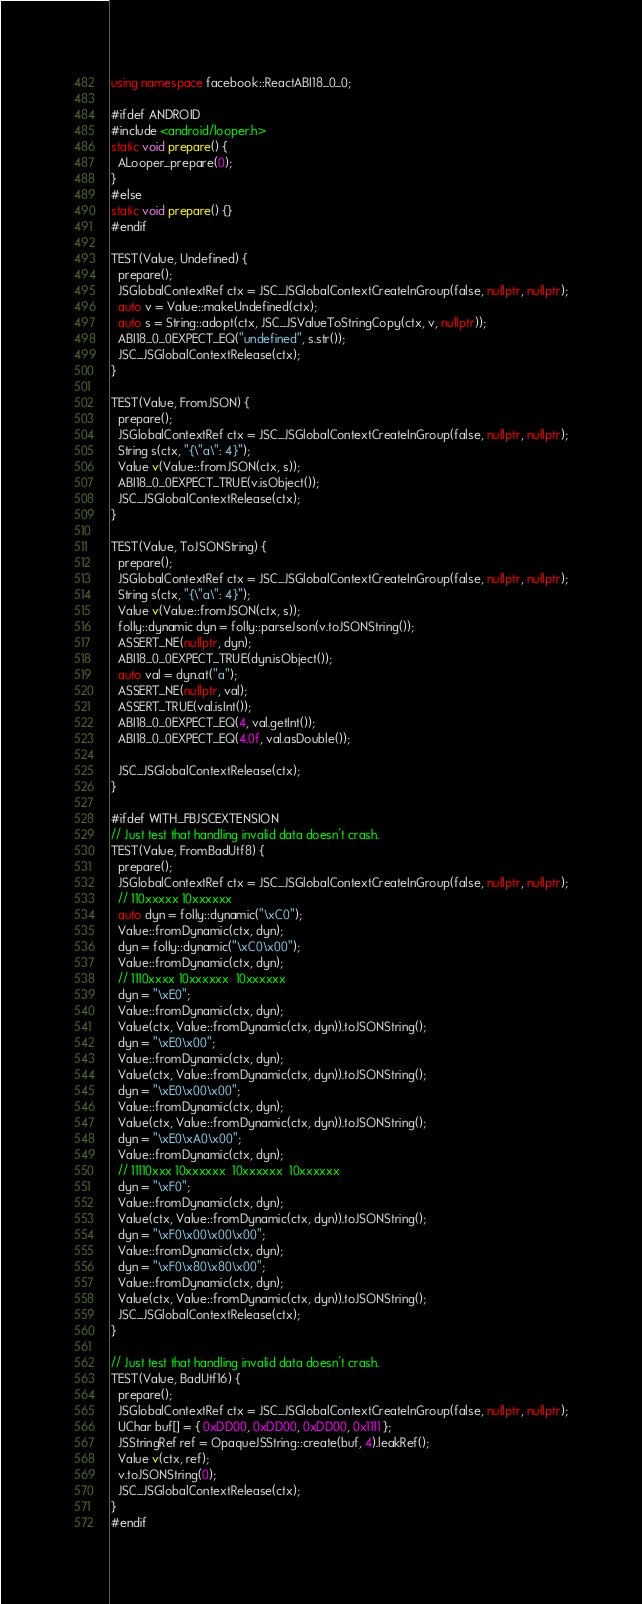<code> <loc_0><loc_0><loc_500><loc_500><_C++_>using namespace facebook::ReactABI18_0_0;

#ifdef ANDROID
#include <android/looper.h>
static void prepare() {
  ALooper_prepare(0);
}
#else
static void prepare() {}
#endif

TEST(Value, Undefined) {
  prepare();
  JSGlobalContextRef ctx = JSC_JSGlobalContextCreateInGroup(false, nullptr, nullptr);
  auto v = Value::makeUndefined(ctx);
  auto s = String::adopt(ctx, JSC_JSValueToStringCopy(ctx, v, nullptr));
  ABI18_0_0EXPECT_EQ("undefined", s.str());
  JSC_JSGlobalContextRelease(ctx);
}

TEST(Value, FromJSON) {
  prepare();
  JSGlobalContextRef ctx = JSC_JSGlobalContextCreateInGroup(false, nullptr, nullptr);
  String s(ctx, "{\"a\": 4}");
  Value v(Value::fromJSON(ctx, s));
  ABI18_0_0EXPECT_TRUE(v.isObject());
  JSC_JSGlobalContextRelease(ctx);
}

TEST(Value, ToJSONString) {
  prepare();
  JSGlobalContextRef ctx = JSC_JSGlobalContextCreateInGroup(false, nullptr, nullptr);
  String s(ctx, "{\"a\": 4}");
  Value v(Value::fromJSON(ctx, s));
  folly::dynamic dyn = folly::parseJson(v.toJSONString());
  ASSERT_NE(nullptr, dyn);
  ABI18_0_0EXPECT_TRUE(dyn.isObject());
  auto val = dyn.at("a");
  ASSERT_NE(nullptr, val);
  ASSERT_TRUE(val.isInt());
  ABI18_0_0EXPECT_EQ(4, val.getInt());
  ABI18_0_0EXPECT_EQ(4.0f, val.asDouble());

  JSC_JSGlobalContextRelease(ctx);
}

#ifdef WITH_FBJSCEXTENSION
// Just test that handling invalid data doesn't crash.
TEST(Value, FromBadUtf8) {
  prepare();
  JSGlobalContextRef ctx = JSC_JSGlobalContextCreateInGroup(false, nullptr, nullptr);
  // 110xxxxx 10xxxxxx
  auto dyn = folly::dynamic("\xC0");
  Value::fromDynamic(ctx, dyn);
  dyn = folly::dynamic("\xC0\x00");
  Value::fromDynamic(ctx, dyn);
  // 1110xxxx 10xxxxxx  10xxxxxx
  dyn = "\xE0";
  Value::fromDynamic(ctx, dyn);
  Value(ctx, Value::fromDynamic(ctx, dyn)).toJSONString();
  dyn = "\xE0\x00";
  Value::fromDynamic(ctx, dyn);
  Value(ctx, Value::fromDynamic(ctx, dyn)).toJSONString();
  dyn = "\xE0\x00\x00";
  Value::fromDynamic(ctx, dyn);
  Value(ctx, Value::fromDynamic(ctx, dyn)).toJSONString();
  dyn = "\xE0\xA0\x00";
  Value::fromDynamic(ctx, dyn);
  // 11110xxx 10xxxxxx  10xxxxxx  10xxxxxx
  dyn = "\xF0";
  Value::fromDynamic(ctx, dyn);
  Value(ctx, Value::fromDynamic(ctx, dyn)).toJSONString();
  dyn = "\xF0\x00\x00\x00";
  Value::fromDynamic(ctx, dyn);
  dyn = "\xF0\x80\x80\x00";
  Value::fromDynamic(ctx, dyn);
  Value(ctx, Value::fromDynamic(ctx, dyn)).toJSONString();
  JSC_JSGlobalContextRelease(ctx);
}

// Just test that handling invalid data doesn't crash.
TEST(Value, BadUtf16) {
  prepare();
  JSGlobalContextRef ctx = JSC_JSGlobalContextCreateInGroup(false, nullptr, nullptr);
  UChar buf[] = { 0xDD00, 0xDD00, 0xDD00, 0x1111 };
  JSStringRef ref = OpaqueJSString::create(buf, 4).leakRef();
  Value v(ctx, ref);
  v.toJSONString(0);
  JSC_JSGlobalContextRelease(ctx);
}
#endif
</code> 